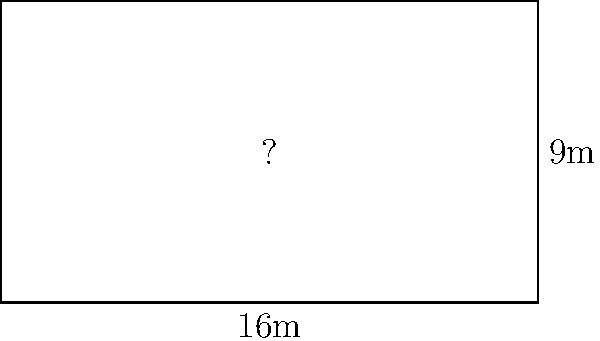In a modern cinema showcasing both PewDiePie's YouTube Rewind and T-Series' music videos, the rectangular screen measures 16 meters in width and 9 meters in height. What is the aspect ratio of this screen in its simplest form? To determine the aspect ratio of the cinema screen, we need to follow these steps:

1. Identify the dimensions:
   Width = 16 meters
   Height = 9 meters

2. Express the ratio of width to height:
   Aspect Ratio = Width : Height
   Aspect Ratio = 16 : 9

3. Simplify the ratio:
   In this case, 16:9 is already in its simplest form as both numbers are divisible only by 1.

4. Express the aspect ratio in the standard format:
   Aspect Ratio = 16:9

This 16:9 aspect ratio is common in modern widescreen formats, which is fitting for showcasing both YouTube content (like PewDiePie's videos) and professional music videos (like those from T-Series). This format provides a cinematic experience while accommodating various types of digital content.
Answer: 16:9 